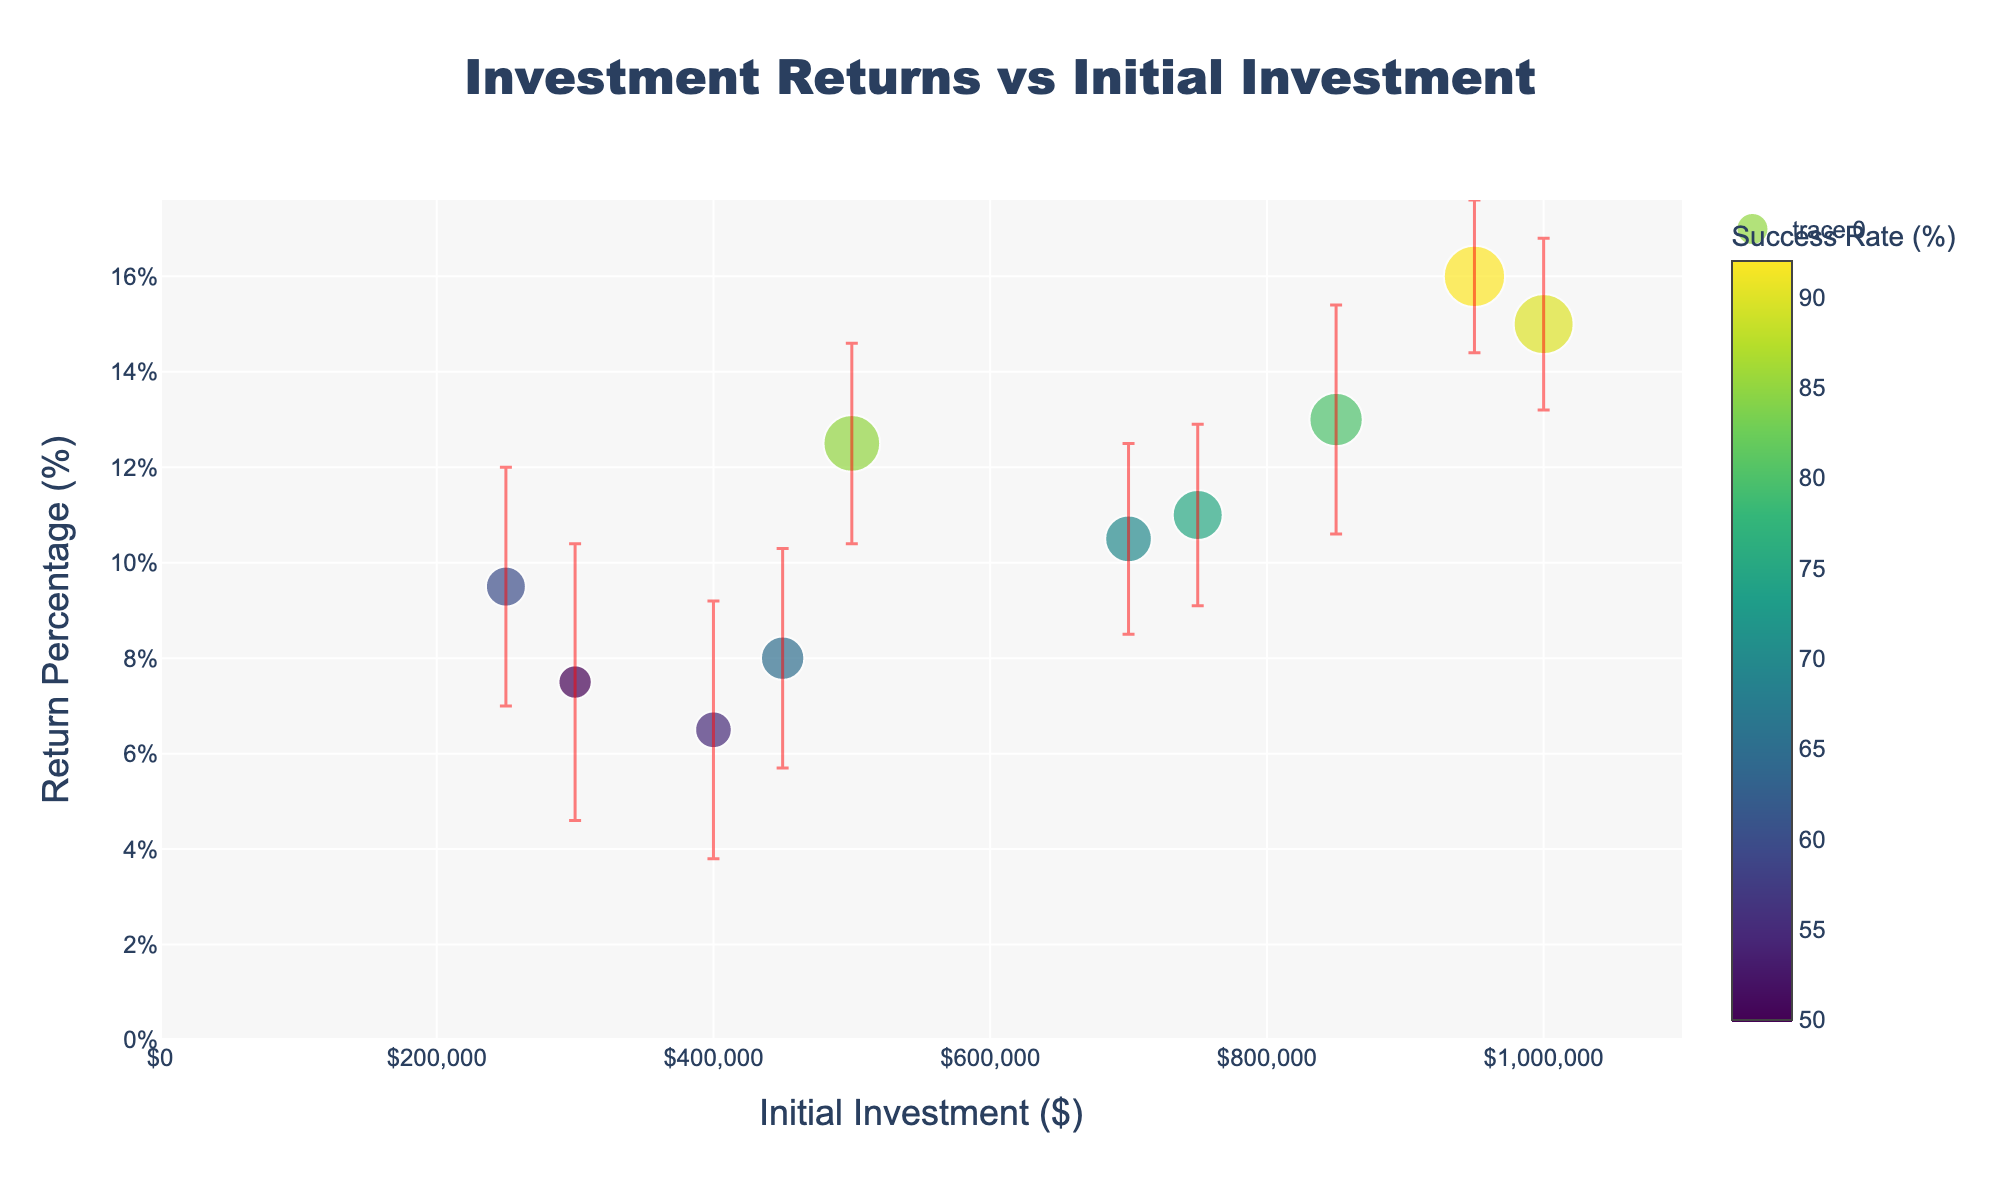What is the title of the figure? The title is located at the top center of the figure and reads "Investment Returns vs Initial Investment".
Answer: Investment Returns vs Initial Investment How many companies are represented in the figure? Each dot in the plot represents one company, and you can count a total of 10 dots.
Answer: 10 Which company has the highest success rate? By referring to the color scale and finding the darkest dot, you locate LambdaConsulting with a success rate of 92%.
Answer: LambdaConsulting What is the range of initial investments shown in the figure? The initial investments range from the minimum value of $250,000 to the maximum value of $1,000,000 as indicated on the x-axis.
Answer: $250,000 to $1,000,000 What is the error margin for the company with the highest return percentage? Locate the company with the highest return percentage on the y-axis (16%). It's LambdaConsulting, which has an error margin of 1.6%.
Answer: 1.6% Which company has the lowest return percentage, and what is it? By identifying the lowest point on the y-axis, you find that KappaLimited has a return percentage of 6.5%.
Answer: KappaLimited, 6.5% Compare the success rates of GammaHoldings and ZetaInvestments. Which is higher? GammaHoldings has a success rate of 60%, while ZetaInvestments has a success rate of 65%. ZetaInvestments is higher.
Answer: ZetaInvestments Calculate the average return percentage of AlphaCorp, BetaEnterprises, and DeltaAssociates. Add the return percentages of AlphaCorp (12.5%), BetaEnterprises (11.0%), and DeltaAssociates (15.0%) and divide by 3: (12.5 + 11.0 + 15.0) / 3 = 12.83
Answer: 12.83% Which companies fall within an initial investment range of $400,000 to $800,000? By looking at the initial investments between $400,000 and $800,000, you identify EpsilonVentures, ZetaInvestments, ThetaPartners, and KappaLimited.
Answer: EpsilonVentures, ZetaInvestments, ThetaPartners, KappaLimited What is the difference in return percentages between AlphaCorp and EpsilonVentures? Subtract the return percentage of EpsilonVentures (7.5%) from AlphaCorp (12.5%): 12.5% - 7.5% = 5%
Answer: 5% 